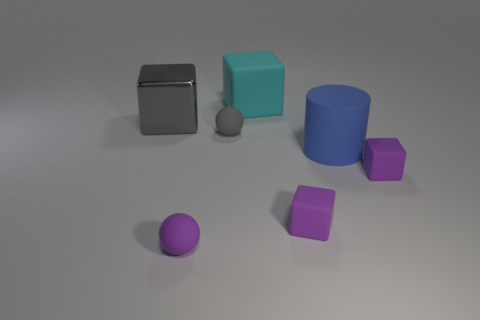The big rubber thing in front of the large matte object that is behind the small gray object is what shape?
Keep it short and to the point. Cylinder. What number of matte cubes are the same size as the gray matte sphere?
Give a very brief answer. 2. Are any gray spheres visible?
Your response must be concise. Yes. Is there any other thing that is the same color as the big metal cube?
Give a very brief answer. Yes. What shape is the big cyan object that is made of the same material as the purple ball?
Make the answer very short. Cube. What color is the large thing right of the large block to the right of the cube left of the small gray rubber ball?
Provide a succinct answer. Blue. Are there the same number of cylinders left of the purple ball and small purple spheres?
Provide a succinct answer. No. Is there any other thing that is made of the same material as the large gray object?
Provide a succinct answer. No. Do the shiny block and the small matte thing behind the big blue matte cylinder have the same color?
Give a very brief answer. Yes. There is a large matte object in front of the cube left of the small gray matte object; are there any tiny gray matte spheres that are to the left of it?
Provide a short and direct response. Yes. 